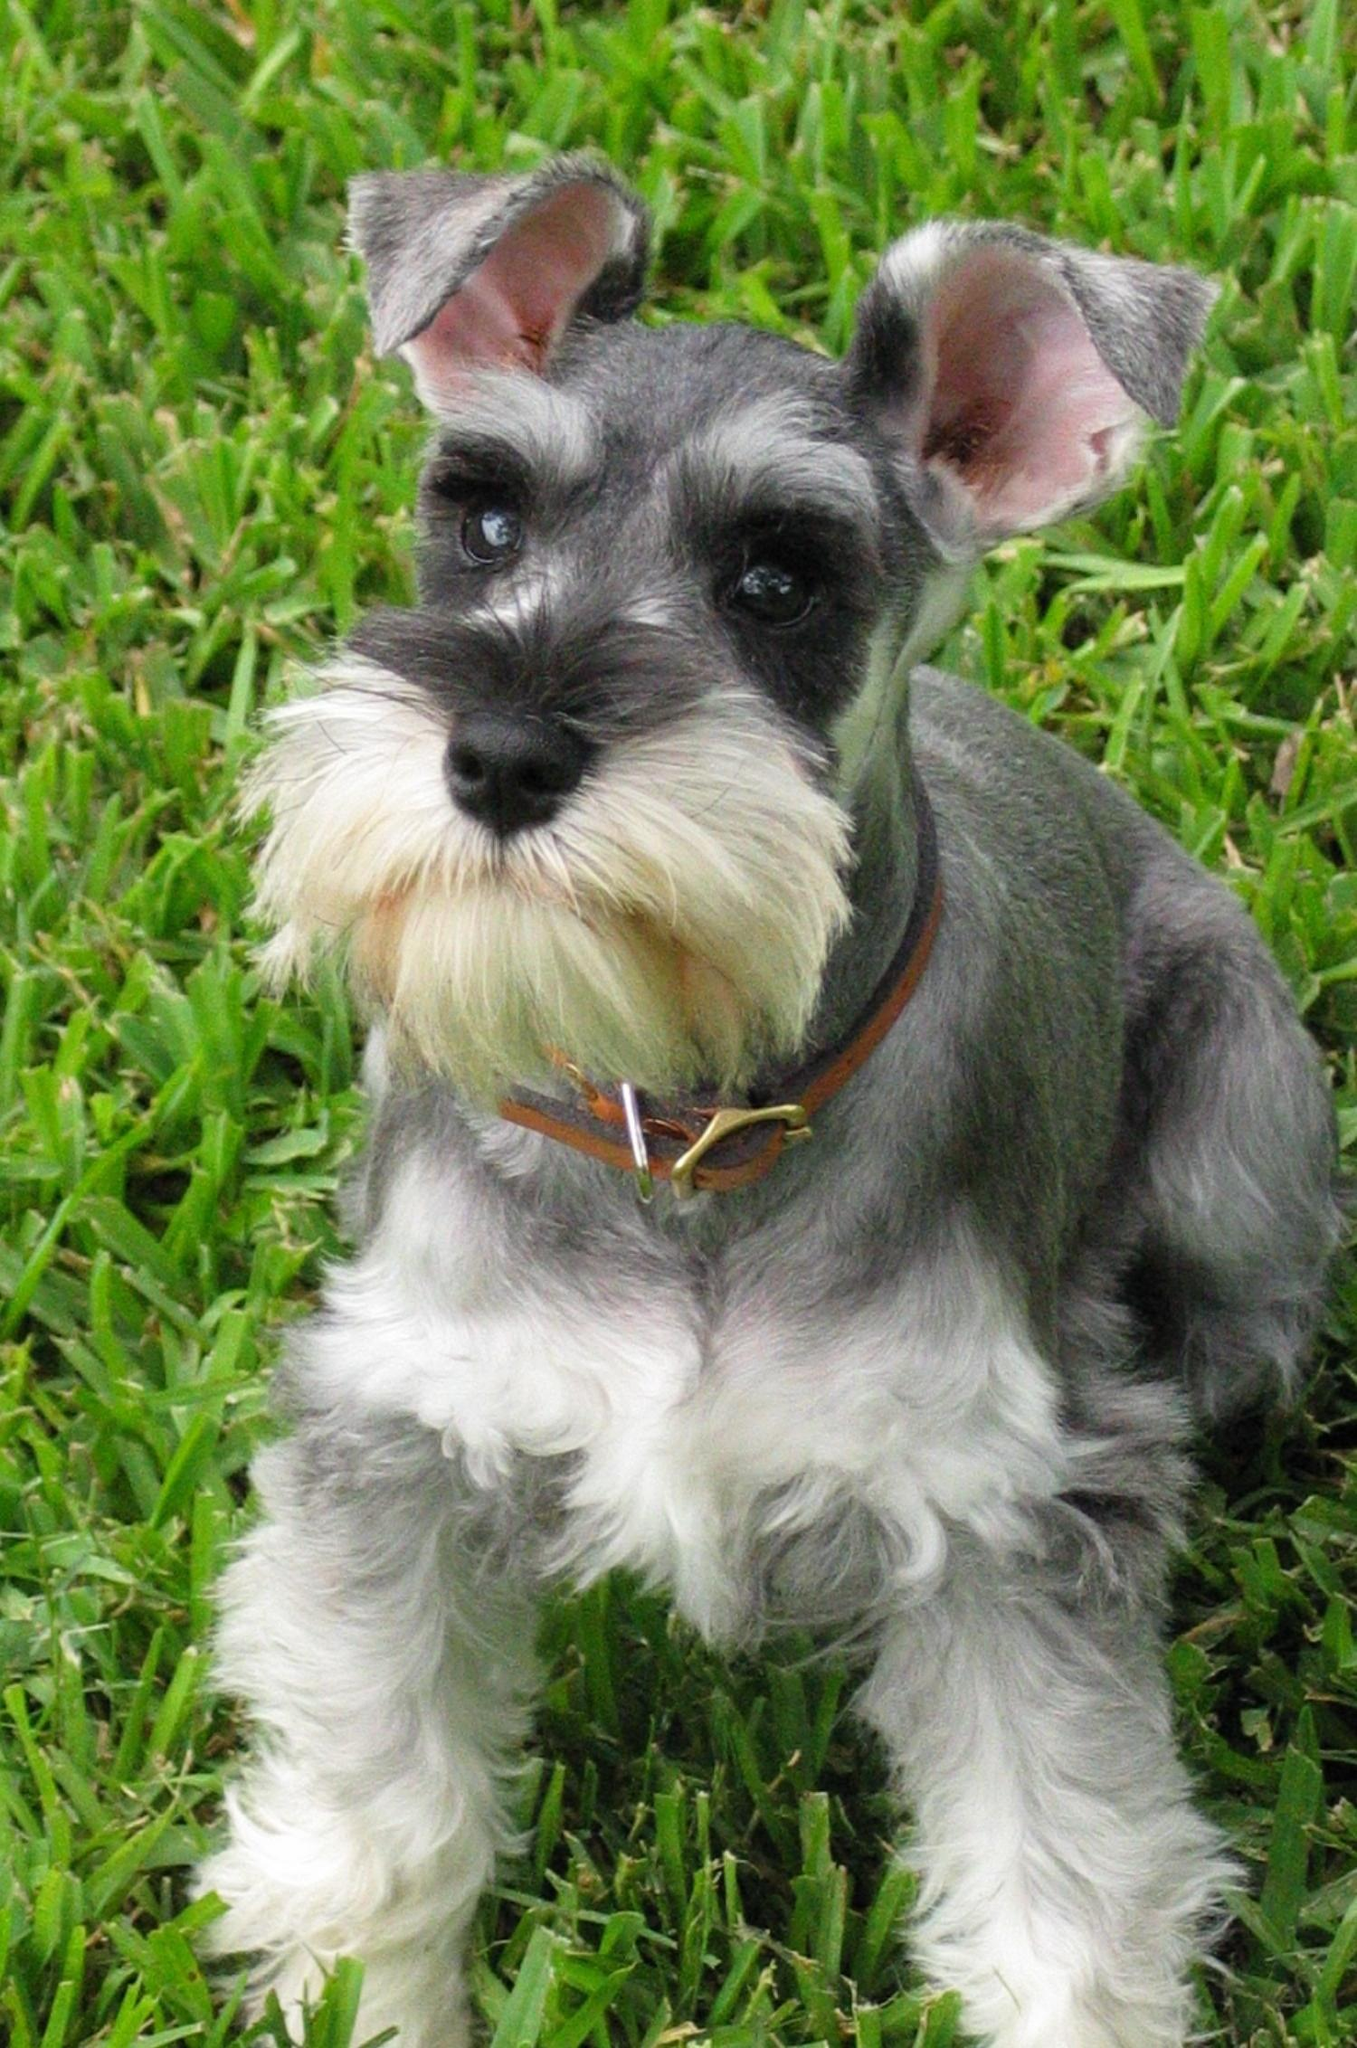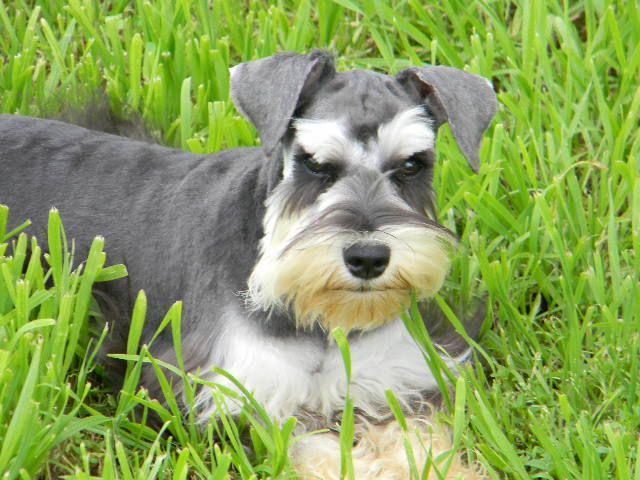The first image is the image on the left, the second image is the image on the right. For the images displayed, is the sentence "A dog's collar is visible." factually correct? Answer yes or no. Yes. 